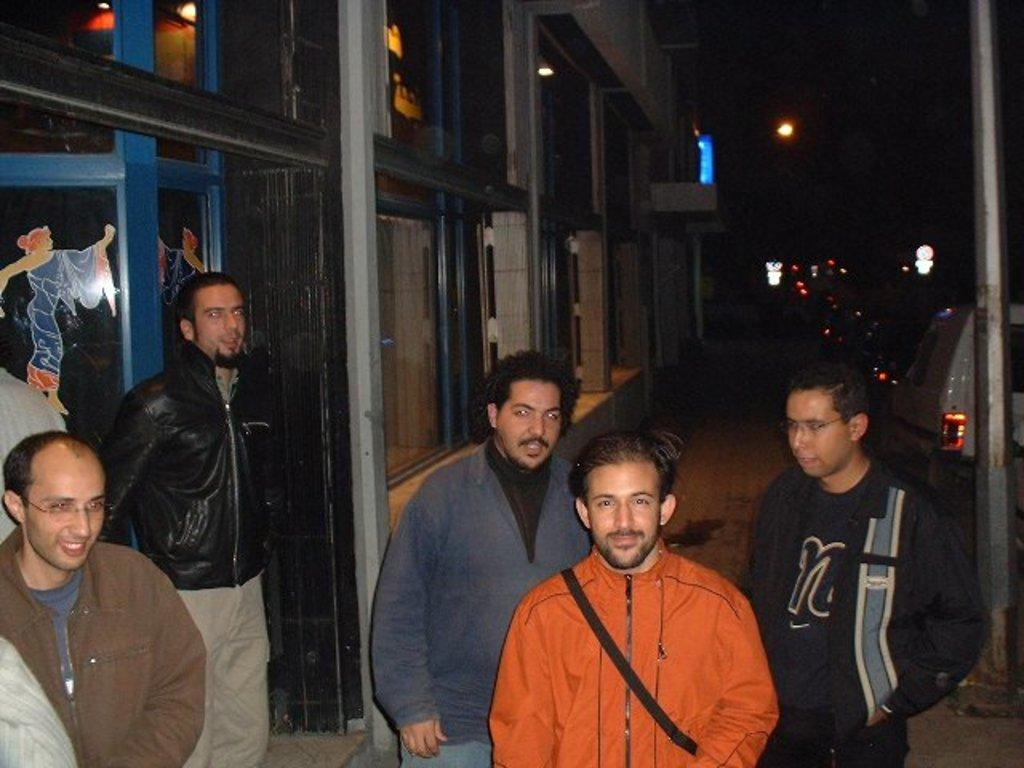How many people are in the image? There are people in the image, but the exact number is not specified. What are the people wearing in the image? The people in the image are wearing coats. Can you describe any accessories the people are wearing? One person is wearing a bag. What can be seen in the background of the image? In the background of the image, there are vehicles, lights, and a building. What type of chain is being used to secure the jar in the image? There is no jar or chain present in the image. What type of laborer can be seen working in the image? There is no laborer present in the image. 